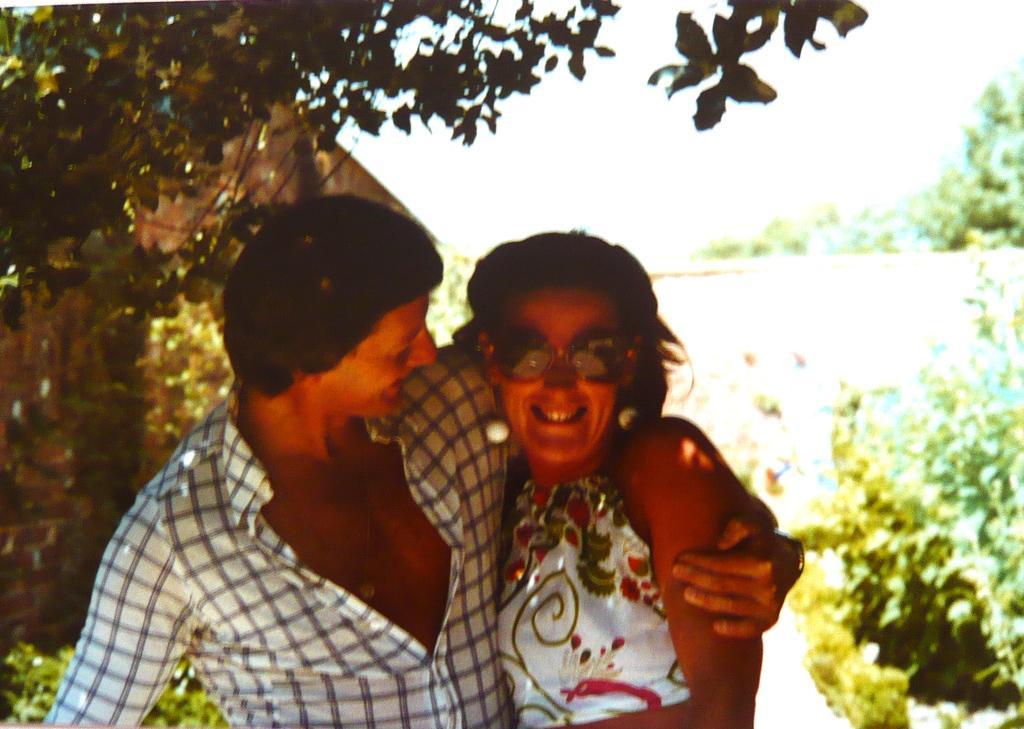Please provide a concise description of this image. In this image there is a couple with a smile on their face, behind them there is a house with red bricks, trees, plants and the sky. 